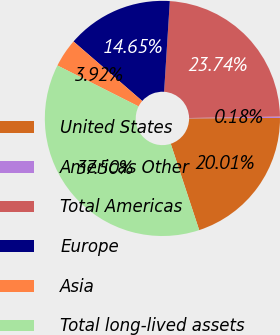<chart> <loc_0><loc_0><loc_500><loc_500><pie_chart><fcel>United States<fcel>Americas Other<fcel>Total Americas<fcel>Europe<fcel>Asia<fcel>Total long-lived assets<nl><fcel>20.01%<fcel>0.18%<fcel>23.74%<fcel>14.65%<fcel>3.92%<fcel>37.5%<nl></chart> 